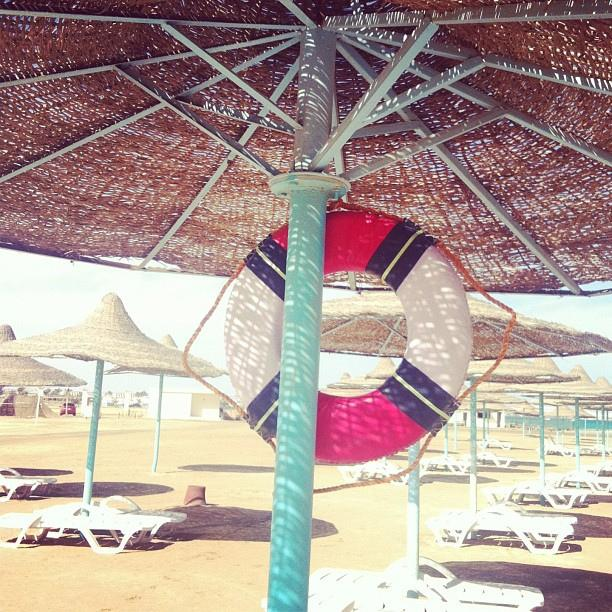The shade held by the teal umbrella pole was crafted in which manner?

Choices:
A) carving
B) sewing machine
C) weaving
D) axe weaving 